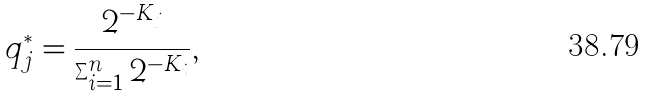<formula> <loc_0><loc_0><loc_500><loc_500>q ^ { * } _ { j } = \frac { 2 ^ { - K _ { j } } } { \sum _ { i = 1 } ^ { n } { 2 ^ { - K _ { i } } } } ,</formula> 